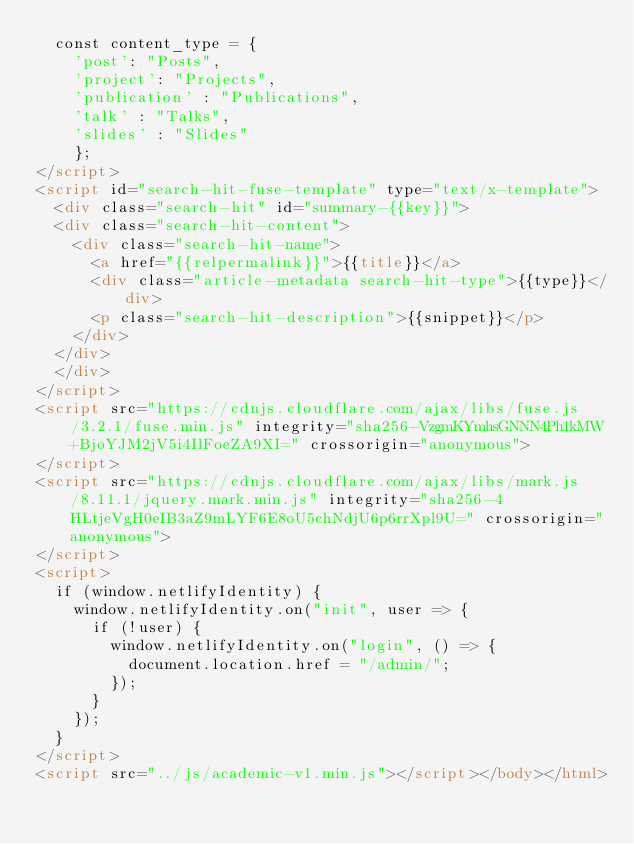Convert code to text. <code><loc_0><loc_0><loc_500><loc_500><_HTML_>	const content_type = {
	  'post': "Posts",
	  'project': "Projects",
	  'publication' : "Publications",
	  'talk' : "Talks",
	  'slides' : "Slides"
	  };
</script>
<script id="search-hit-fuse-template" type="text/x-template">
	<div class="search-hit" id="summary-{{key}}">
	<div class="search-hit-content">
	  <div class="search-hit-name">
	    <a href="{{relpermalink}}">{{title}}</a>
	    <div class="article-metadata search-hit-type">{{type}}</div>
	    <p class="search-hit-description">{{snippet}}</p>
	  </div>
	</div>
	</div>
</script>
<script src="https://cdnjs.cloudflare.com/ajax/libs/fuse.js/3.2.1/fuse.min.js" integrity="sha256-VzgmKYmhsGNNN4Ph1kMW+BjoYJM2jV5i4IlFoeZA9XI=" crossorigin="anonymous">
</script>
<script src="https://cdnjs.cloudflare.com/ajax/libs/mark.js/8.11.1/jquery.mark.min.js" integrity="sha256-4HLtjeVgH0eIB3aZ9mLYF6E8oU5chNdjU6p6rrXpl9U=" crossorigin="anonymous">
</script>
<script>
	if (window.netlifyIdentity) {
	  window.netlifyIdentity.on("init", user => {
	    if (!user) {
	      window.netlifyIdentity.on("login", () => {
	        document.location.href = "/admin/";
	      });
	    }
	  });
	}
</script>
<script src="../js/academic-v1.min.js"></script></body></html>
</code> 